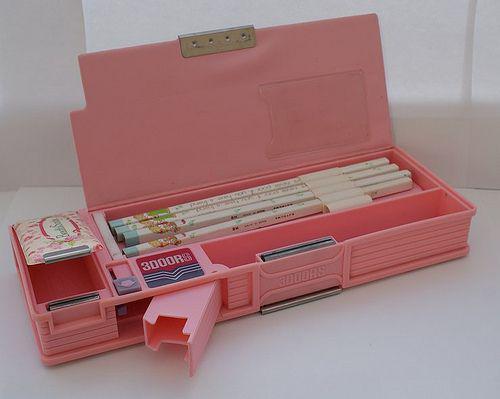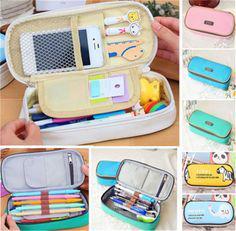The first image is the image on the left, the second image is the image on the right. For the images displayed, is the sentence "At least one pencil case does not use a zipper to close." factually correct? Answer yes or no. Yes. The first image is the image on the left, the second image is the image on the right. Examine the images to the left and right. Is the description "The left image shows just one cyindrical pencil case." accurate? Answer yes or no. No. 